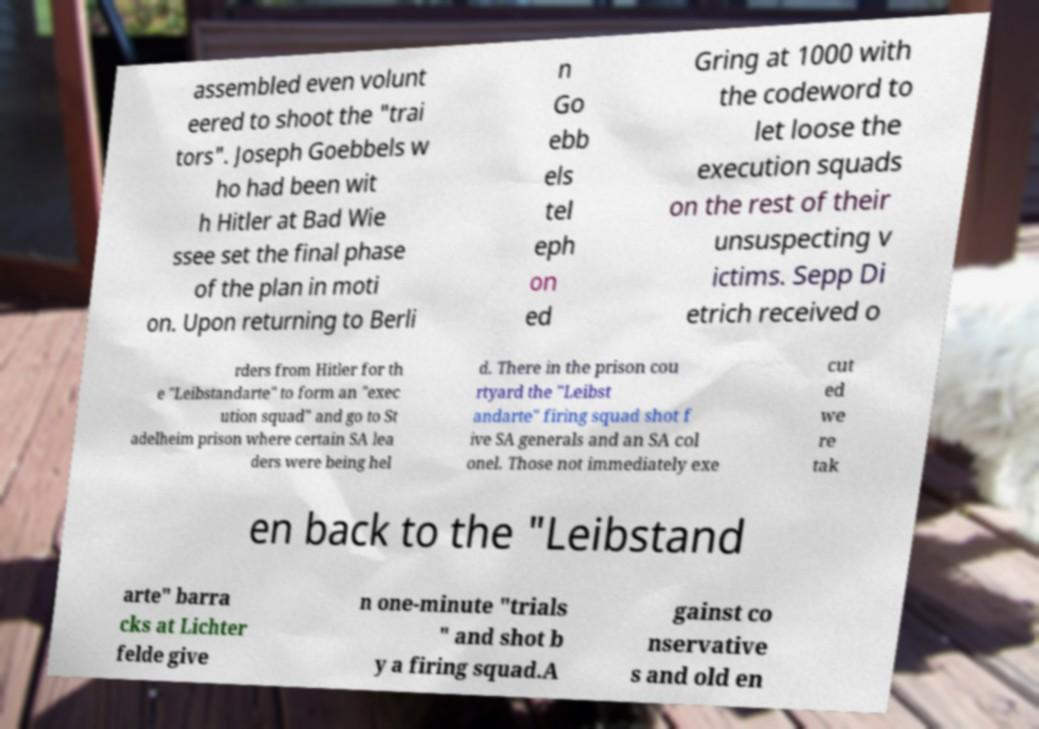There's text embedded in this image that I need extracted. Can you transcribe it verbatim? assembled even volunt eered to shoot the "trai tors". Joseph Goebbels w ho had been wit h Hitler at Bad Wie ssee set the final phase of the plan in moti on. Upon returning to Berli n Go ebb els tel eph on ed Gring at 1000 with the codeword to let loose the execution squads on the rest of their unsuspecting v ictims. Sepp Di etrich received o rders from Hitler for th e "Leibstandarte" to form an "exec ution squad" and go to St adelheim prison where certain SA lea ders were being hel d. There in the prison cou rtyard the "Leibst andarte" firing squad shot f ive SA generals and an SA col onel. Those not immediately exe cut ed we re tak en back to the "Leibstand arte" barra cks at Lichter felde give n one-minute "trials " and shot b y a firing squad.A gainst co nservative s and old en 